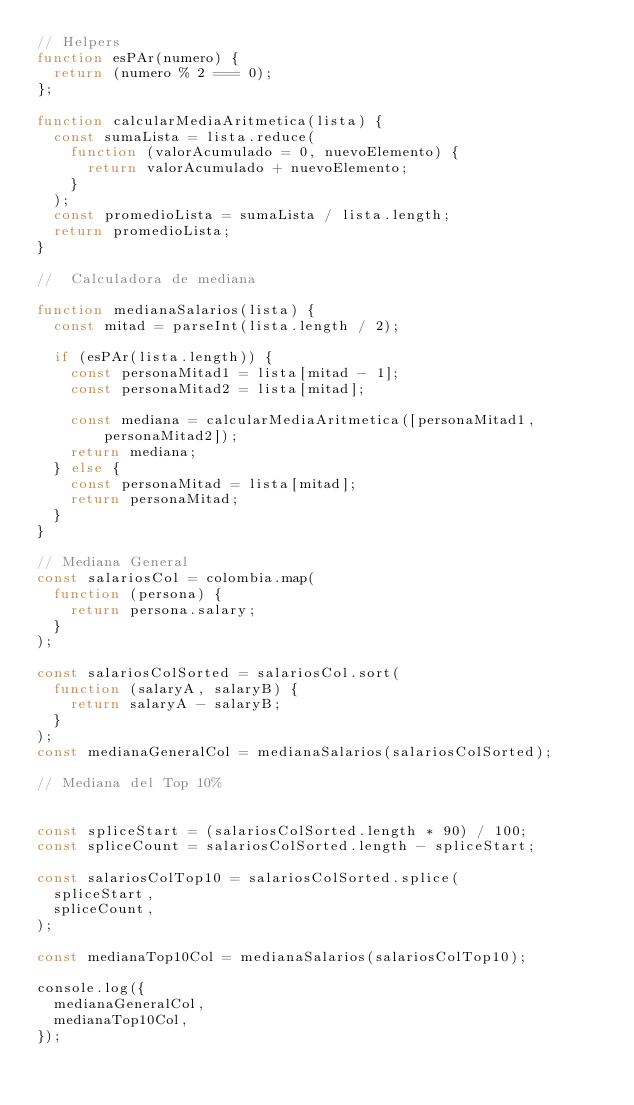Convert code to text. <code><loc_0><loc_0><loc_500><loc_500><_JavaScript_>// Helpers
function esPAr(numero) {
  return (numero % 2 === 0);
};

function calcularMediaAritmetica(lista) {
  const sumaLista = lista.reduce(
    function (valorAcumulado = 0, nuevoElemento) {
      return valorAcumulado + nuevoElemento; 
    }
  );
  const promedioLista = sumaLista / lista.length;
  return promedioLista;
}

//  Calculadora de mediana

function medianaSalarios(lista) {
  const mitad = parseInt(lista.length / 2);
  
  if (esPAr(lista.length)) {
    const personaMitad1 = lista[mitad - 1];
    const personaMitad2 = lista[mitad];
    
    const mediana = calcularMediaAritmetica([personaMitad1, personaMitad2]);
    return mediana;
  } else {
    const personaMitad = lista[mitad];
    return personaMitad;
  }
}

// Mediana General
const salariosCol = colombia.map(
  function (persona) {
    return persona.salary;
  }
);

const salariosColSorted = salariosCol.sort(
  function (salaryA, salaryB) {
    return salaryA - salaryB;
  }
);
const medianaGeneralCol = medianaSalarios(salariosColSorted);

// Mediana del Top 10%


const spliceStart = (salariosColSorted.length * 90) / 100;
const spliceCount = salariosColSorted.length - spliceStart;

const salariosColTop10 = salariosColSorted.splice(
  spliceStart,
  spliceCount,
);

const medianaTop10Col = medianaSalarios(salariosColTop10);

console.log({
  medianaGeneralCol,
  medianaTop10Col,
});</code> 